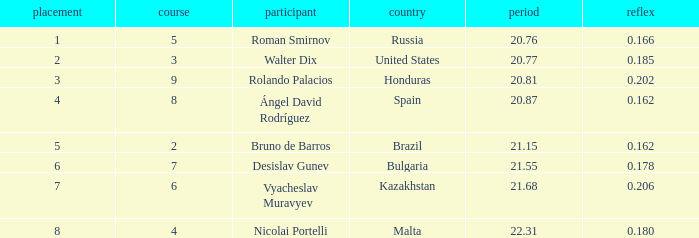What's Russia's lane when they were ranked before 1? None. 